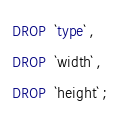<code> <loc_0><loc_0><loc_500><loc_500><_SQL_>DROP  `type` ,
DROP  `width` ,
DROP  `height` ;</code> 